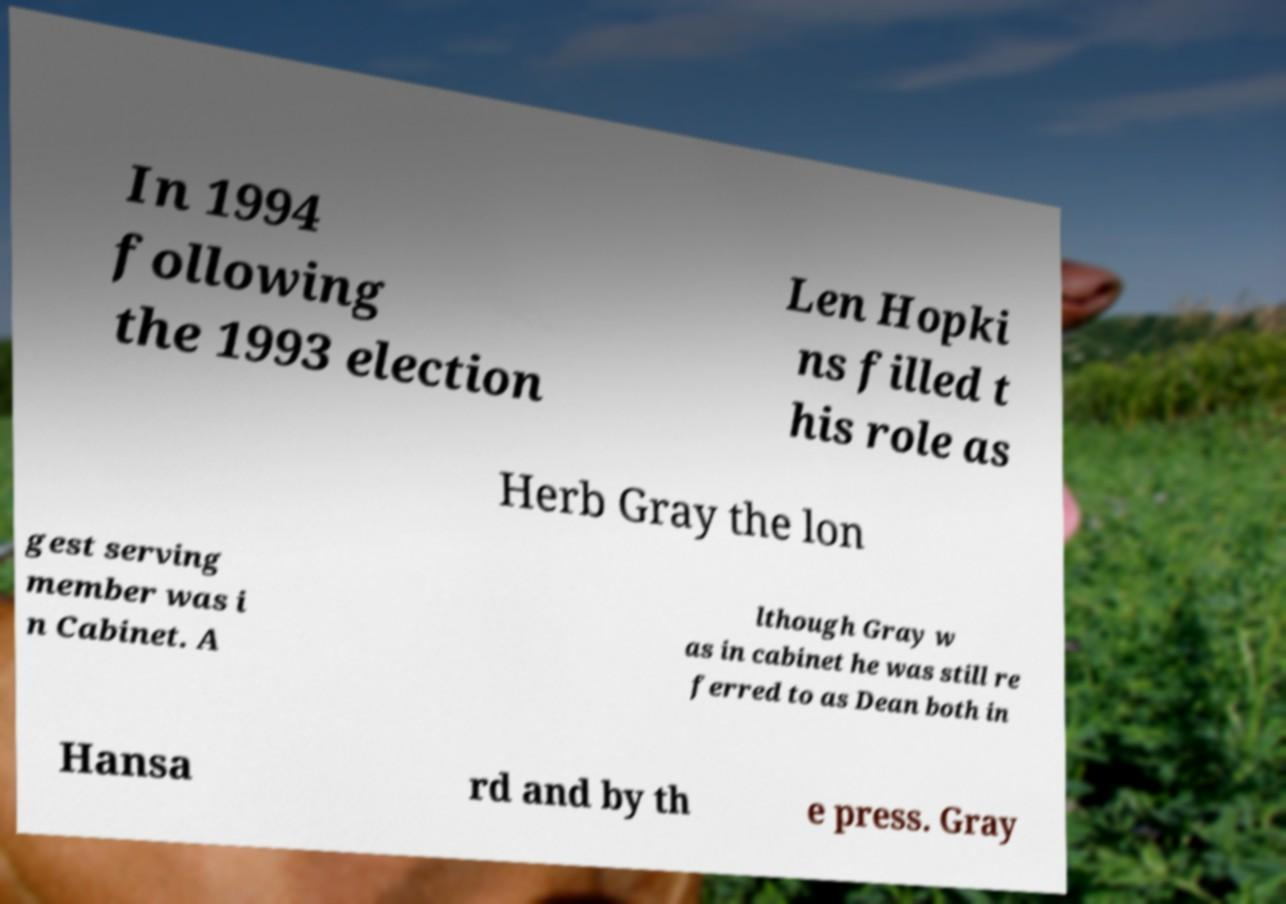Can you read and provide the text displayed in the image?This photo seems to have some interesting text. Can you extract and type it out for me? In 1994 following the 1993 election Len Hopki ns filled t his role as Herb Gray the lon gest serving member was i n Cabinet. A lthough Gray w as in cabinet he was still re ferred to as Dean both in Hansa rd and by th e press. Gray 